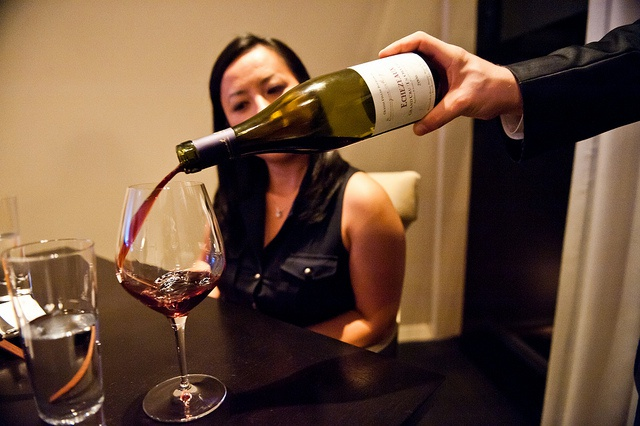Describe the objects in this image and their specific colors. I can see people in black, maroon, brown, and tan tones, dining table in black, maroon, and gray tones, people in black, maroon, brown, and tan tones, bottle in black, olive, maroon, and ivory tones, and cup in black, maroon, and gray tones in this image. 